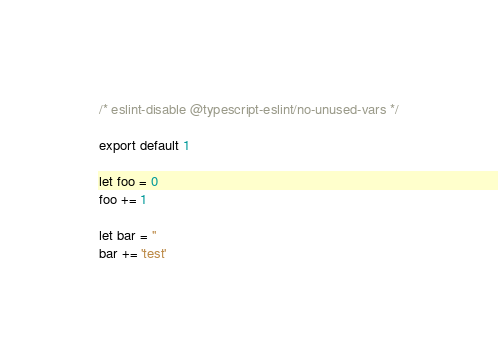Convert code to text. <code><loc_0><loc_0><loc_500><loc_500><_TypeScript_>/* eslint-disable @typescript-eslint/no-unused-vars */

export default 1

let foo = 0
foo += 1

let bar = ''
bar += 'test'
</code> 